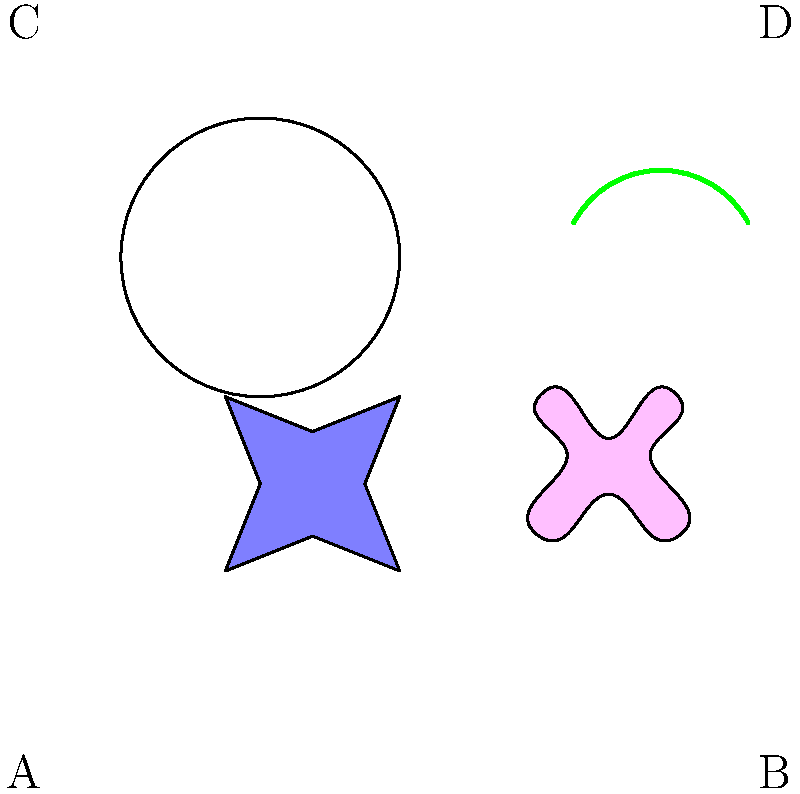Which symbol in the image is commonly associated with peace across various cultures and is often used in international peace movements? To answer this question, let's analyze each symbol:

1. Symbol A (bottom-left): This is a dove. The dove has been a symbol of peace in many cultures, particularly in Western traditions. It is often depicted carrying an olive branch, emphasizing its peaceful symbolism.

2. Symbol B (bottom-right): This represents a lotus flower. While the lotus is a symbol of purity, enlightenment, and rebirth in many Eastern cultures, it is not universally recognized as a symbol of peace.

3. Symbol C (top-left): This is the Yin-Yang symbol from Chinese philosophy. It represents balance and harmony but is not specifically a symbol of peace.

4. Symbol D (top-right): This appears to be an olive branch. The olive branch is another symbol of peace, often used in conjunction with the dove.

Among these symbols, the dove (Symbol A) is the most universally recognized symbol of peace. It has been adopted by various international peace movements and organizations, including the United Nations. The dove's association with peace dates back to biblical times and has transcended cultural boundaries to become a global symbol of peace and hope.
Answer: Dove (Symbol A) 